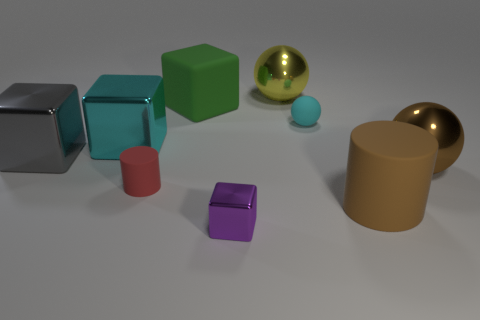There is a big brown rubber thing; what number of brown matte cylinders are in front of it?
Your answer should be very brief. 0. Are the cyan thing that is right of the yellow object and the ball that is in front of the large gray metal object made of the same material?
Provide a succinct answer. No. There is a tiny thing that is behind the brown shiny ball to the right of the shiny cube that is in front of the small red rubber cylinder; what shape is it?
Give a very brief answer. Sphere. What is the shape of the green rubber object?
Offer a terse response. Cube. The cyan thing that is the same size as the red matte thing is what shape?
Give a very brief answer. Sphere. What number of other objects are there of the same color as the tiny matte cylinder?
Provide a short and direct response. 0. There is a cyan thing on the left side of the small shiny thing; is its shape the same as the red thing to the right of the cyan block?
Your answer should be very brief. No. What number of objects are matte things to the left of the tiny cyan ball or metal things on the right side of the small rubber cylinder?
Offer a very short reply. 5. What number of other things are there of the same material as the big cyan object
Provide a succinct answer. 4. Do the cube behind the large cyan metallic object and the purple block have the same material?
Provide a succinct answer. No. 